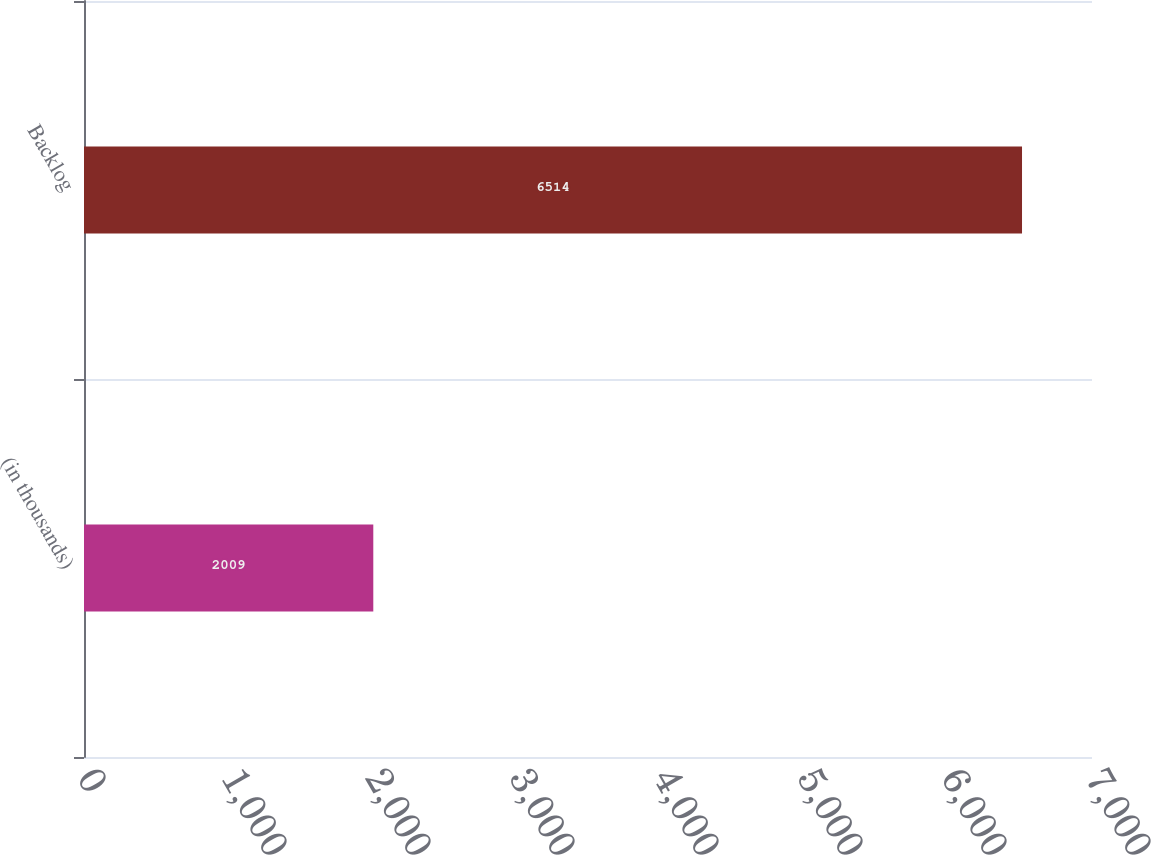<chart> <loc_0><loc_0><loc_500><loc_500><bar_chart><fcel>(in thousands)<fcel>Backlog<nl><fcel>2009<fcel>6514<nl></chart> 